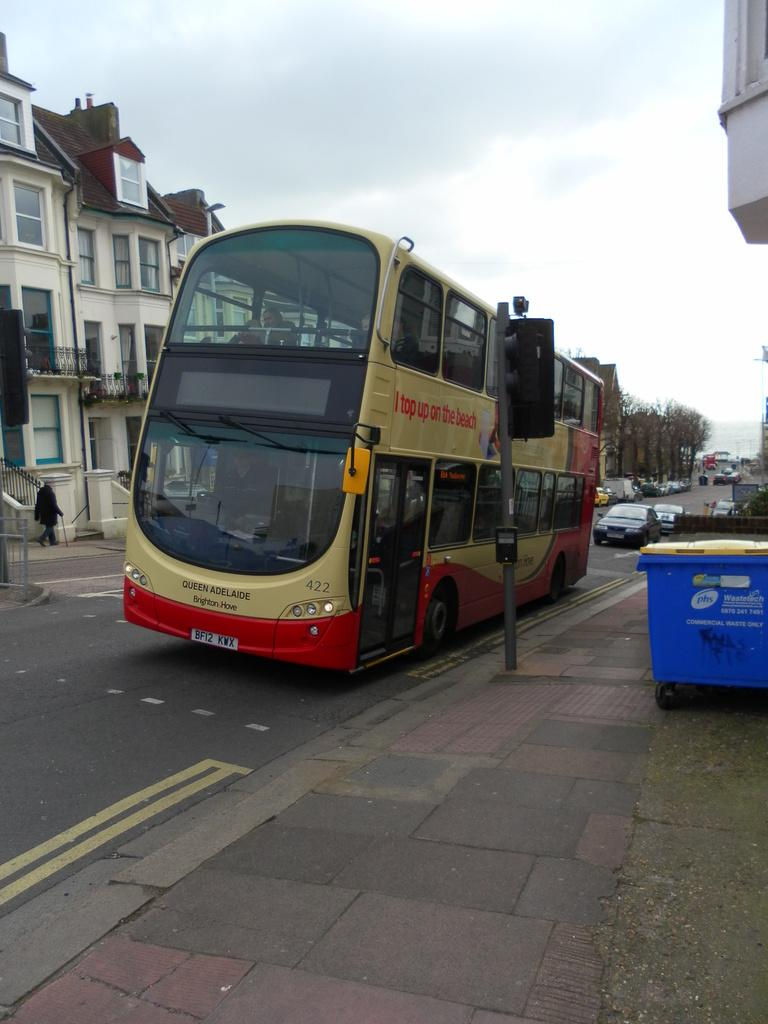What is the main subject in the center of the image? There is a bus in the center of the image. What type of structures can be seen on the left side of the image? There are buildings on the left side of the image. What type of vehicles are on the right side of the image? There are cars on the right side of the image. What type of bubble can be seen floating near the bus in the image? There is no bubble present in the image. 